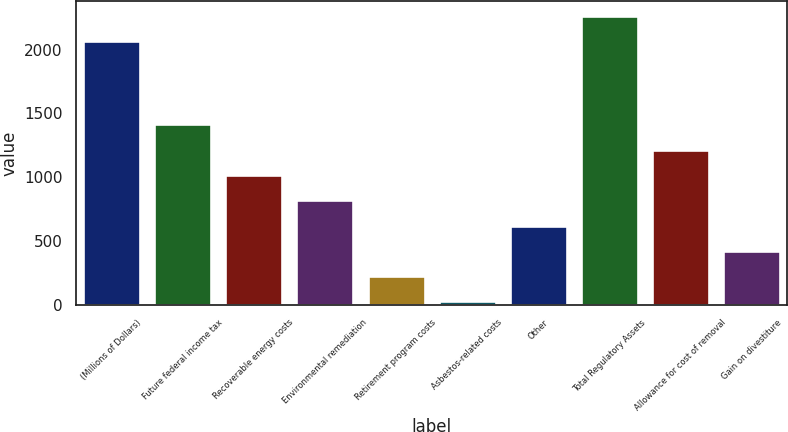Convert chart to OTSL. <chart><loc_0><loc_0><loc_500><loc_500><bar_chart><fcel>(Millions of Dollars)<fcel>Future federal income tax<fcel>Recoverable energy costs<fcel>Environmental remediation<fcel>Retirement program costs<fcel>Asbestos-related costs<fcel>Other<fcel>Total Regulatory Assets<fcel>Allowance for cost of removal<fcel>Gain on divestiture<nl><fcel>2066.5<fcel>1414.5<fcel>1017.5<fcel>819<fcel>223.5<fcel>25<fcel>620.5<fcel>2265<fcel>1216<fcel>422<nl></chart> 